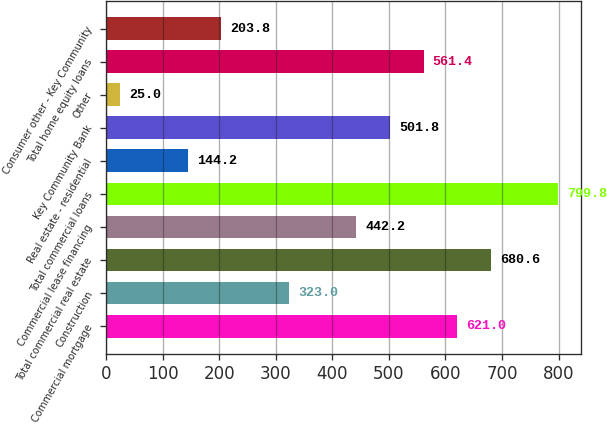Convert chart to OTSL. <chart><loc_0><loc_0><loc_500><loc_500><bar_chart><fcel>Commercial mortgage<fcel>Construction<fcel>Total commercial real estate<fcel>Commercial lease financing<fcel>Total commercial loans<fcel>Real estate - residential<fcel>Key Community Bank<fcel>Other<fcel>Total home equity loans<fcel>Consumer other - Key Community<nl><fcel>621<fcel>323<fcel>680.6<fcel>442.2<fcel>799.8<fcel>144.2<fcel>501.8<fcel>25<fcel>561.4<fcel>203.8<nl></chart> 